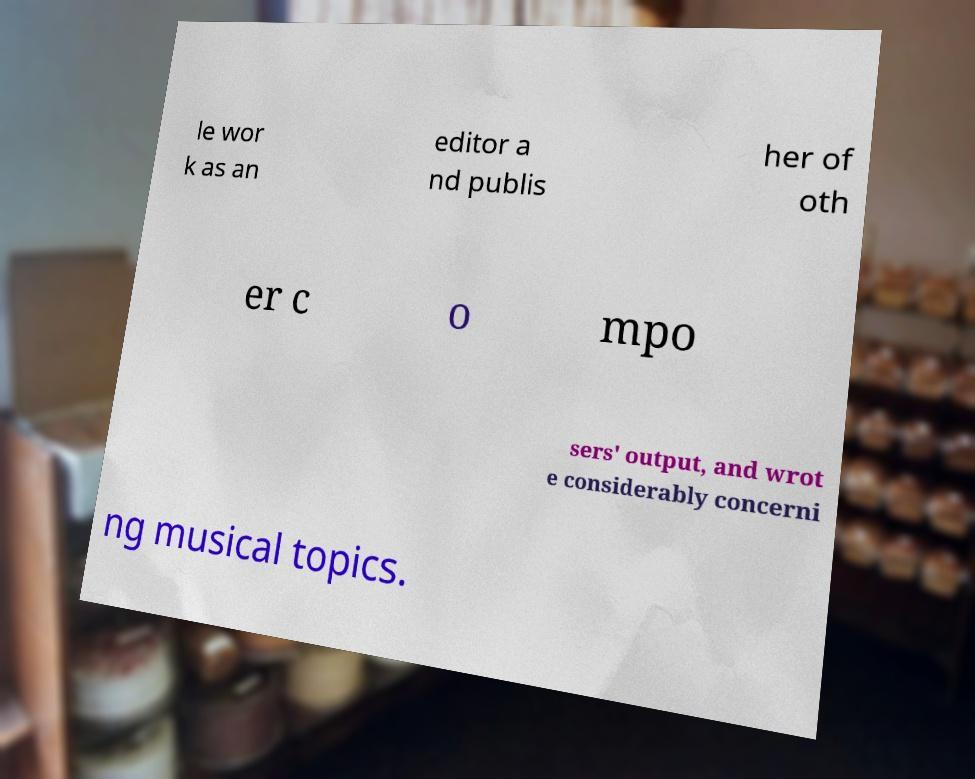Please identify and transcribe the text found in this image. le wor k as an editor a nd publis her of oth er c o mpo sers' output, and wrot e considerably concerni ng musical topics. 